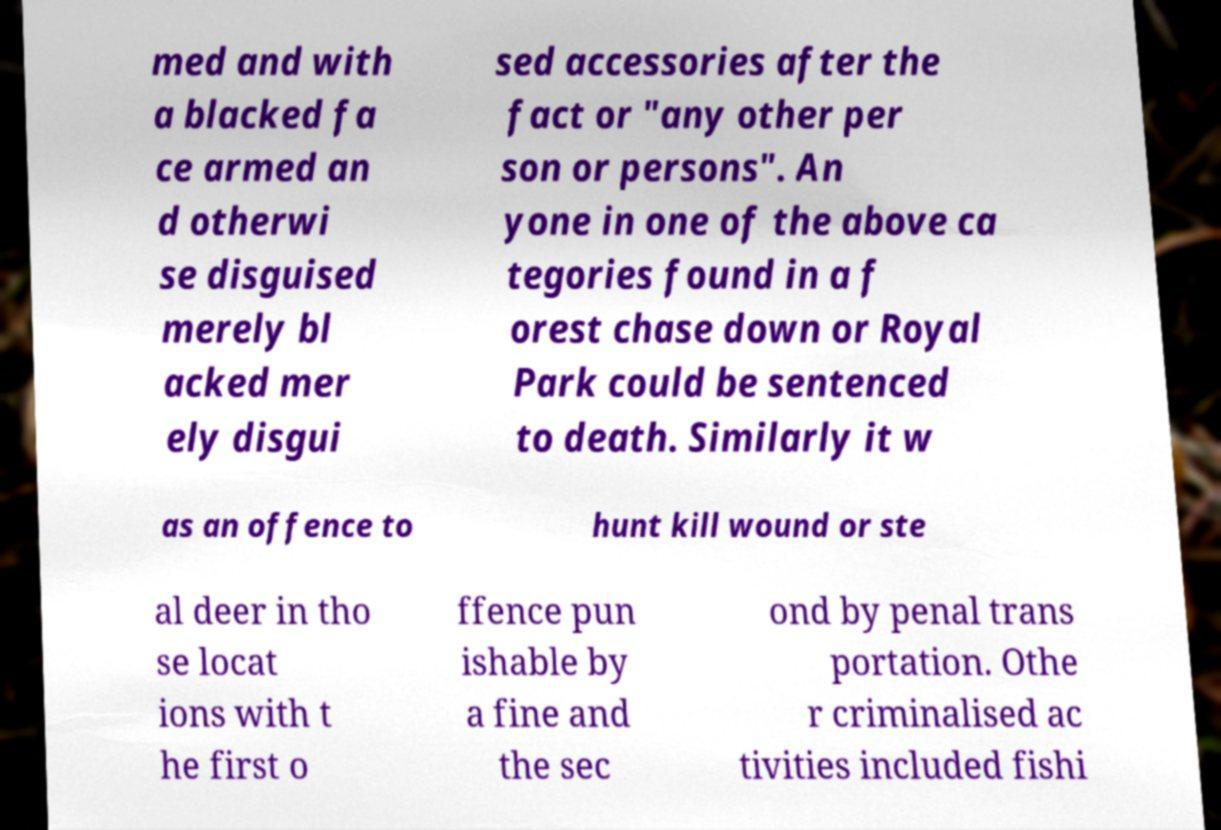There's text embedded in this image that I need extracted. Can you transcribe it verbatim? med and with a blacked fa ce armed an d otherwi se disguised merely bl acked mer ely disgui sed accessories after the fact or "any other per son or persons". An yone in one of the above ca tegories found in a f orest chase down or Royal Park could be sentenced to death. Similarly it w as an offence to hunt kill wound or ste al deer in tho se locat ions with t he first o ffence pun ishable by a fine and the sec ond by penal trans portation. Othe r criminalised ac tivities included fishi 